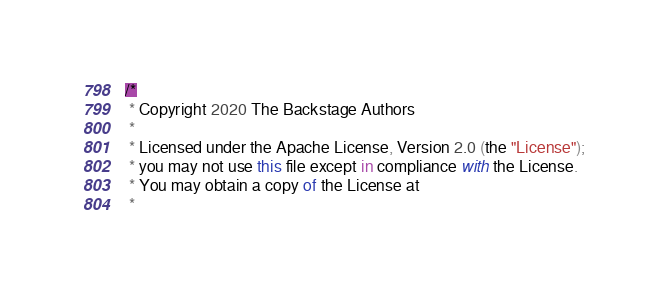Convert code to text. <code><loc_0><loc_0><loc_500><loc_500><_TypeScript_>/*
 * Copyright 2020 The Backstage Authors
 *
 * Licensed under the Apache License, Version 2.0 (the "License");
 * you may not use this file except in compliance with the License.
 * You may obtain a copy of the License at
 *</code> 